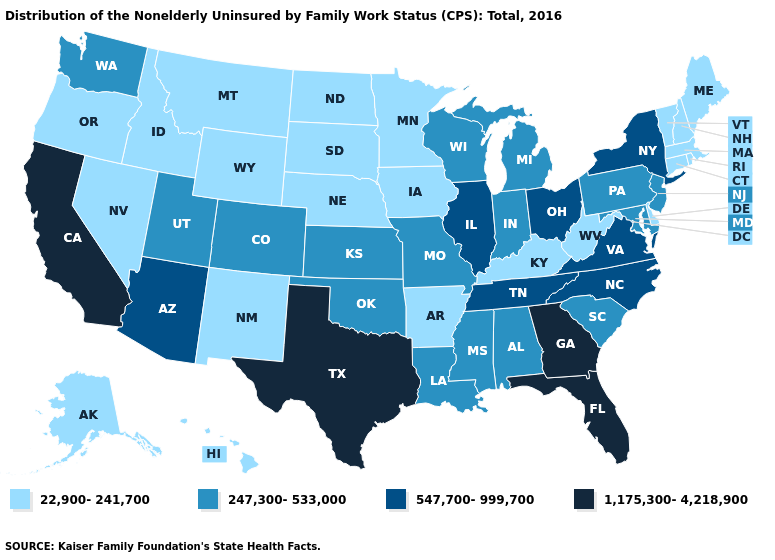What is the value of Connecticut?
Short answer required. 22,900-241,700. Which states have the lowest value in the MidWest?
Short answer required. Iowa, Minnesota, Nebraska, North Dakota, South Dakota. What is the highest value in states that border Tennessee?
Quick response, please. 1,175,300-4,218,900. Which states have the lowest value in the South?
Keep it brief. Arkansas, Delaware, Kentucky, West Virginia. Is the legend a continuous bar?
Keep it brief. No. What is the lowest value in the West?
Keep it brief. 22,900-241,700. Does the first symbol in the legend represent the smallest category?
Quick response, please. Yes. What is the highest value in the South ?
Keep it brief. 1,175,300-4,218,900. Name the states that have a value in the range 22,900-241,700?
Keep it brief. Alaska, Arkansas, Connecticut, Delaware, Hawaii, Idaho, Iowa, Kentucky, Maine, Massachusetts, Minnesota, Montana, Nebraska, Nevada, New Hampshire, New Mexico, North Dakota, Oregon, Rhode Island, South Dakota, Vermont, West Virginia, Wyoming. What is the lowest value in the USA?
Write a very short answer. 22,900-241,700. Name the states that have a value in the range 247,300-533,000?
Write a very short answer. Alabama, Colorado, Indiana, Kansas, Louisiana, Maryland, Michigan, Mississippi, Missouri, New Jersey, Oklahoma, Pennsylvania, South Carolina, Utah, Washington, Wisconsin. What is the value of Connecticut?
Answer briefly. 22,900-241,700. Among the states that border Louisiana , which have the lowest value?
Concise answer only. Arkansas. Which states have the highest value in the USA?
Concise answer only. California, Florida, Georgia, Texas. How many symbols are there in the legend?
Be succinct. 4. 